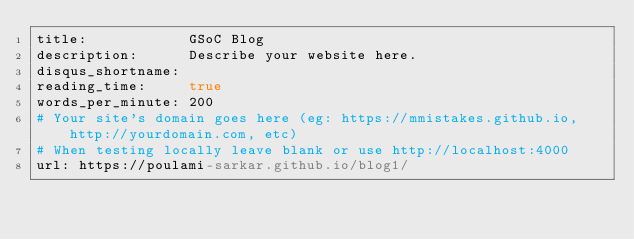Convert code to text. <code><loc_0><loc_0><loc_500><loc_500><_YAML_>title:            GSoC Blog
description:      Describe your website here.
disqus_shortname: 
reading_time:     true
words_per_minute: 200
# Your site's domain goes here (eg: https://mmistakes.github.io, http://yourdomain.com, etc)
# When testing locally leave blank or use http://localhost:4000
url: https://poulami-sarkar.github.io/blog1/
</code> 